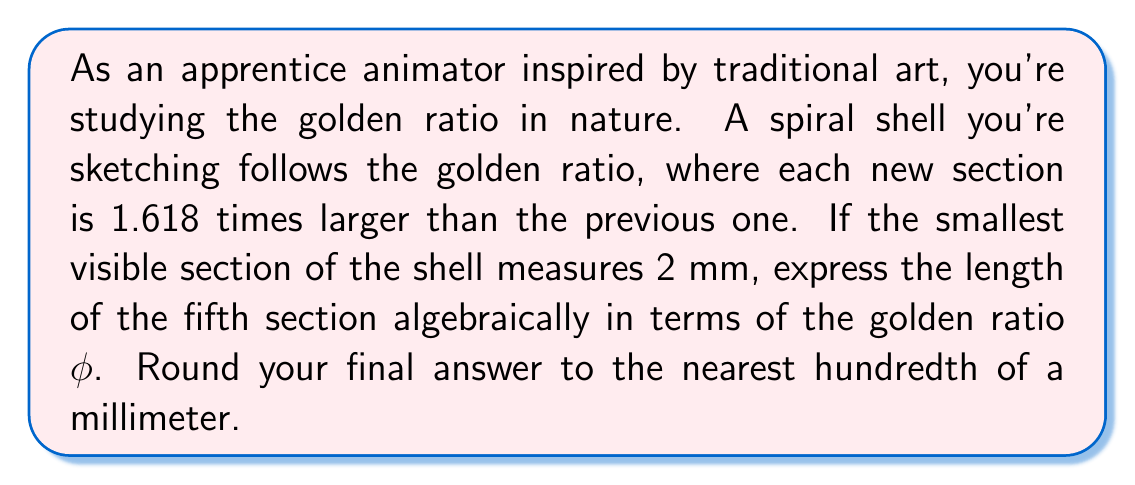What is the answer to this math problem? Let's approach this step-by-step:

1) The golden ratio is denoted by $\phi$ (phi) and is approximately equal to 1.618.

2) We start with the smallest section of 2 mm.

3) Each subsequent section is $\phi$ times larger than the previous one.

4) To find the fifth section, we need to multiply the initial size by $\phi$ four times:

   $$ 2 \cdot \phi \cdot \phi \cdot \phi \cdot \phi = 2 \cdot \phi^4 $$

5) Now, let's calculate this:
   $$ 2 \cdot \phi^4 = 2 \cdot (1.618)^4 $$
   $$ = 2 \cdot 6.854101 $$
   $$ = 13.708202 $$

6) Rounding to the nearest hundredth:
   $$ 13.71 \text{ mm} $$
Answer: $13.71 \text{ mm}$ 